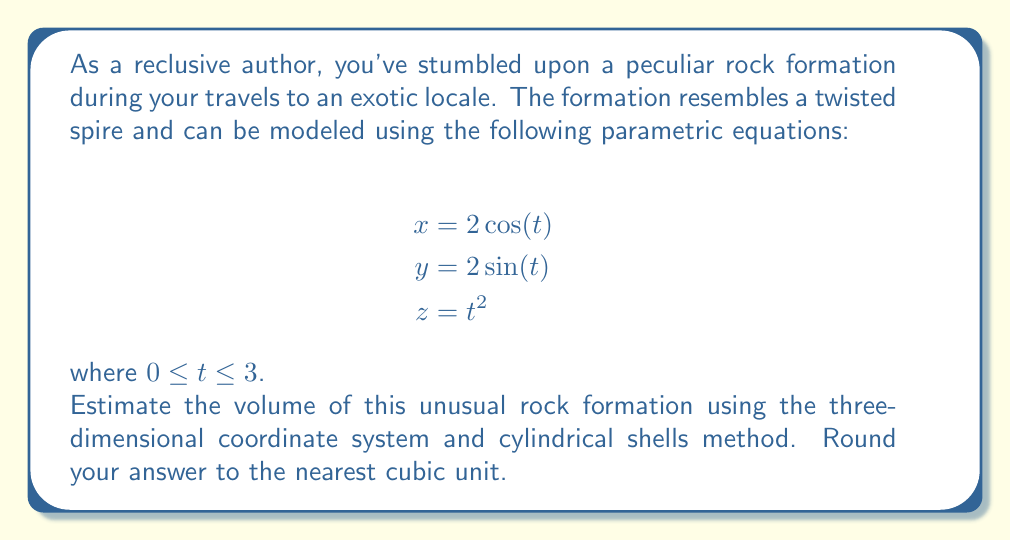Can you solve this math problem? To estimate the volume of this rock formation using cylindrical shells, we'll follow these steps:

1) The volume of a cylindrical shell is given by the formula:
   $$V = 2\pi r h \, dr$$
   where $r$ is the radius of the shell, $h$ is its height, and $dr$ is the thickness of the shell.

2) In our case, $r$ is constant and equal to 2 (from $x$ and $y$ equations).
   The height $h$ is given by the $z$ equation: $z = t^2$

3) We need to express $dr$ in terms of $dt$. Since $r$ is constant, $dr = 0$, but we're integrating with respect to $t$, so we'll use $dt$ instead.

4) Our volume integral becomes:
   $$V = \int_0^3 2\pi (2) (t^2) \, dt$$

5) Simplifying:
   $$V = 4\pi \int_0^3 t^2 \, dt$$

6) Integrating:
   $$V = 4\pi \left[\frac{t^3}{3}\right]_0^3$$

7) Evaluating the integral:
   $$V = 4\pi \left(\frac{27}{3} - 0\right) = 36\pi$$

8) Calculating and rounding to the nearest cubic unit:
   $$V \approx 113 \text{ cubic units}$$
Answer: 113 cubic units 